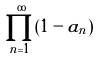Convert formula to latex. <formula><loc_0><loc_0><loc_500><loc_500>\prod _ { n = 1 } ^ { \infty } ( 1 - a _ { n } )</formula> 